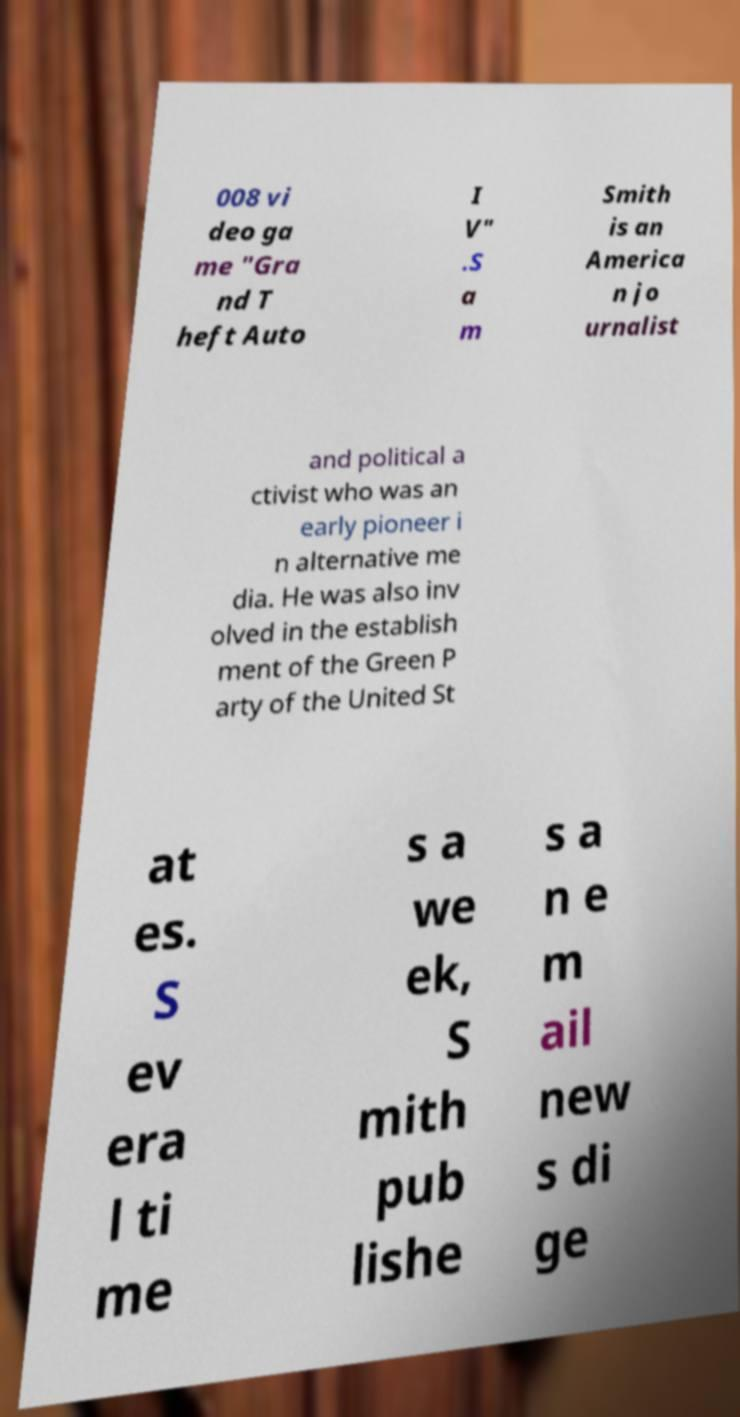Could you extract and type out the text from this image? 008 vi deo ga me "Gra nd T heft Auto I V" .S a m Smith is an America n jo urnalist and political a ctivist who was an early pioneer i n alternative me dia. He was also inv olved in the establish ment of the Green P arty of the United St at es. S ev era l ti me s a we ek, S mith pub lishe s a n e m ail new s di ge 